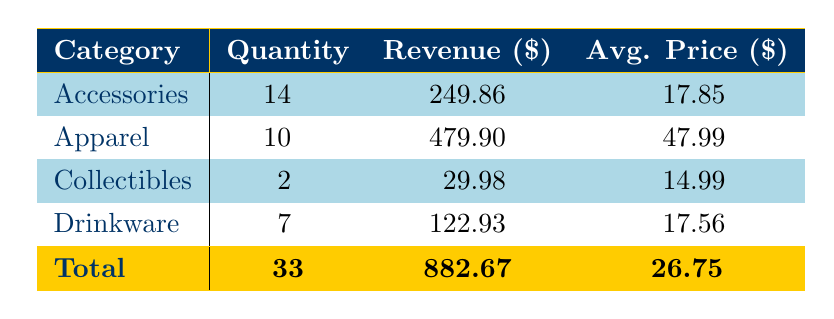What is the total quantity of products sold in the Accessories category? The table shows that for the Accessories category, the quantity is explicitly listed as 14.
Answer: 14 What is the total revenue generated from Apparel sales? The revenue for the Apparel category is listed as 479.90 in the table.
Answer: 479.90 What is the average price of Drinkware products? In the table, the average price for Drinkware is listed as 17.56, which directly answers the question.
Answer: 17.56 Is the total revenue of all categories greater than 800? The total revenue from the table is listed as 882.67, which clearly is greater than 800, so the answer is true.
Answer: Yes How much more revenue did Apparel generate compared to Collectibles? The revenue for Apparel is 479.90 and for Collectibles is 29.98. The difference is calculated as 479.90 - 29.98 = 449.92.
Answer: 449.92 What percentage of the total quantity sold does the Drinkware category represent? The total quantity sold is 33, and Drinkware's quantity is 7. The calculation is (7/33)*100, which gives approximately 21.21%.
Answer: 21.21% Which product category had the highest average price? The average prices from the table are: Apparel 47.99, Accessories 17.85, Collectibles 14.99, Drinkware 17.56. Apparel has the highest at 47.99, making it the answer.
Answer: Apparel What is the total quantity of products sold across all categories? The table provides a total quantity of 33, which is the sum of quantities across all categories.
Answer: 33 Was the revenue for the Accessories category higher than that for Drinkware? The revenue for Accessories is 249.86 and for Drinkware is 122.93. Since 249.86 is greater than 122.93, the answer is yes.
Answer: Yes 